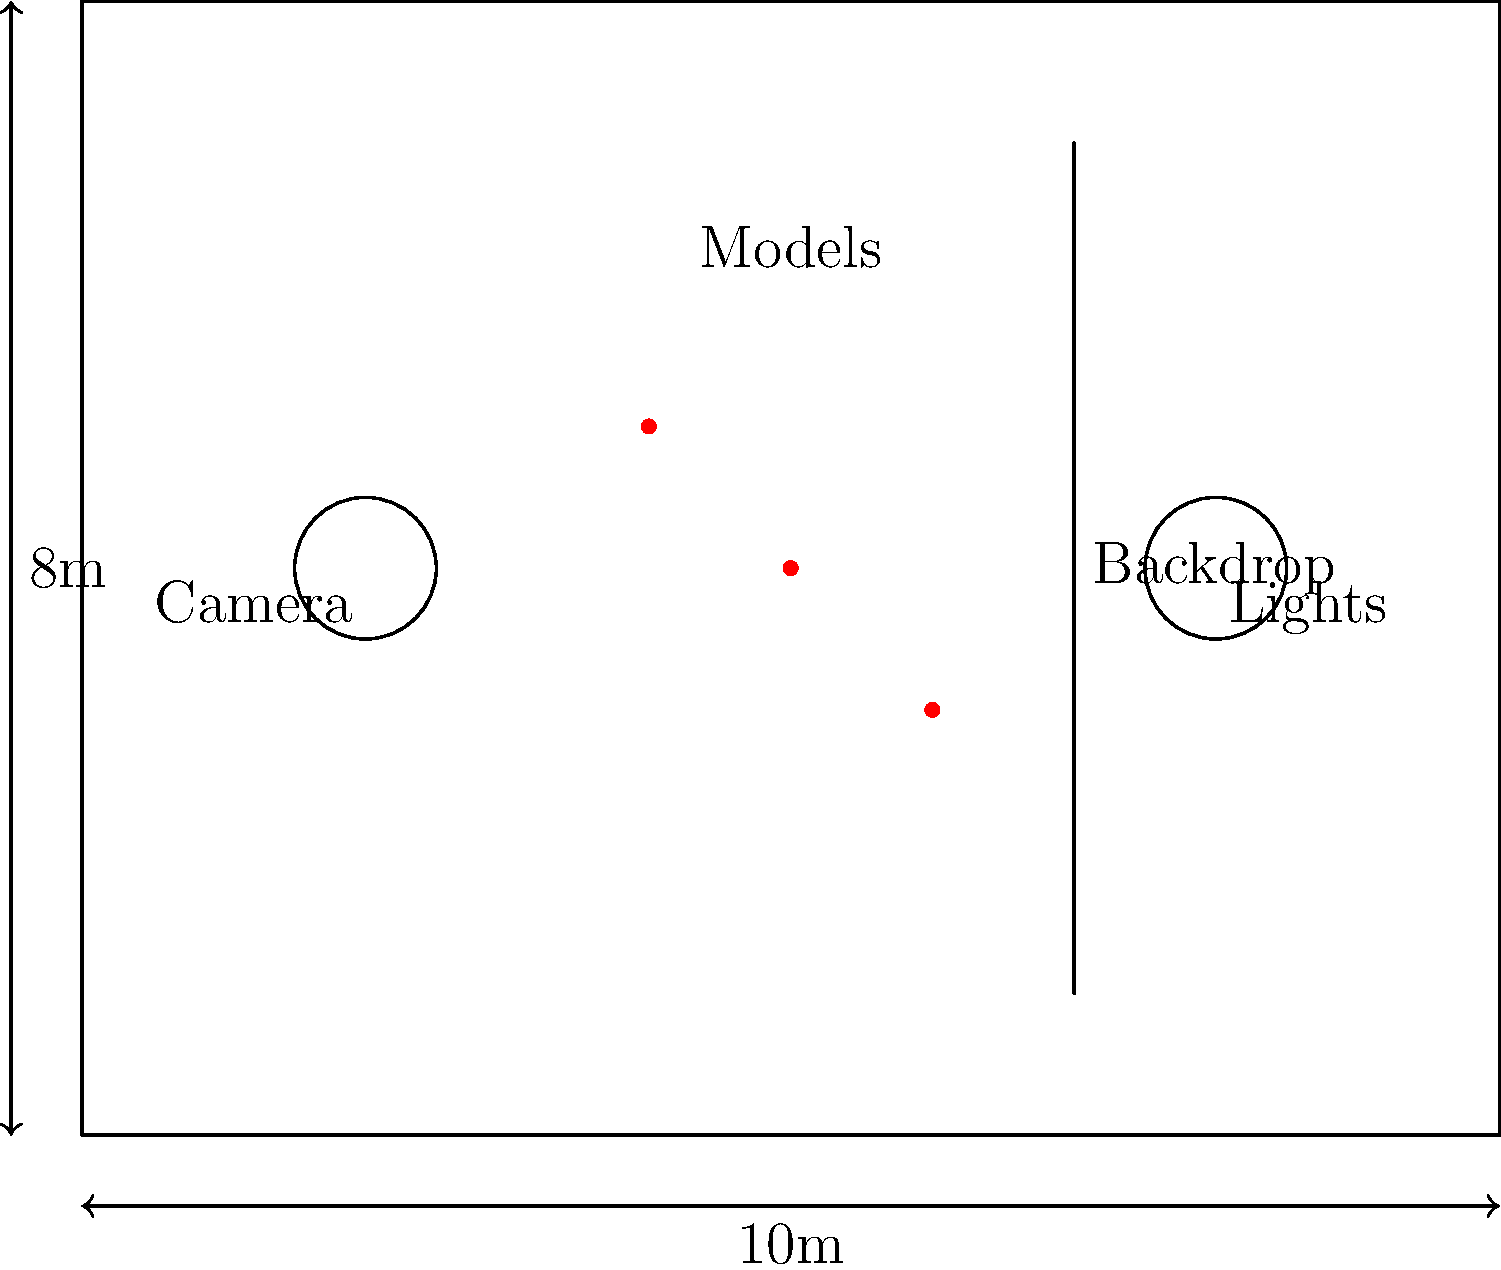You're planning a high-concept photoshoot for a major fashion magazine. The studio has provided you with a floor plan of their space, measuring 10m by 8m. Given the placement of essential equipment (camera, lights, and backdrop) and three model positions as shown in the diagram, what is the minimum circular area needed to encompass all the models while maintaining at least a 1m buffer from any equipment or walls? Express your answer in square meters, rounded to the nearest whole number. To solve this problem, we need to follow these steps:

1. Identify the center point of the circle that encompasses all models:
   - Model 1: (5,4)
   - Model 2: (6,3)
   - Model 3: (4,5)
   The center point (x,y) can be calculated as the average of these coordinates:
   x = (5 + 6 + 4) / 3 = 5
   y = (4 + 3 + 5) / 3 = 4
   So, the center point is (5,4).

2. Calculate the radius of the circle that encompasses all models:
   We need to find the distance from the center point to the farthest model and add 1m for the buffer.
   Using the distance formula: $d = \sqrt{(x_2-x_1)^2 + (y_2-y_1)^2}$
   
   For Model 1: $d = \sqrt{(5-5)^2 + (4-4)^2} = 0$
   For Model 2: $d = \sqrt{(6-5)^2 + (3-4)^2} = \sqrt{2} \approx 1.41$
   For Model 3: $d = \sqrt{(4-5)^2 + (5-4)^2} = \sqrt{2} \approx 1.41$

   The maximum distance is 1.41m. Adding the 1m buffer, the radius becomes 2.41m.

3. Calculate the area of the circle:
   $A = \pi r^2$
   $A = \pi (2.41)^2 \approx 18.24$ square meters

4. Round to the nearest whole number:
   18.24 rounds to 18 square meters.
Answer: 18 m² 